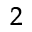<formula> <loc_0><loc_0><loc_500><loc_500>^ { 2 }</formula> 